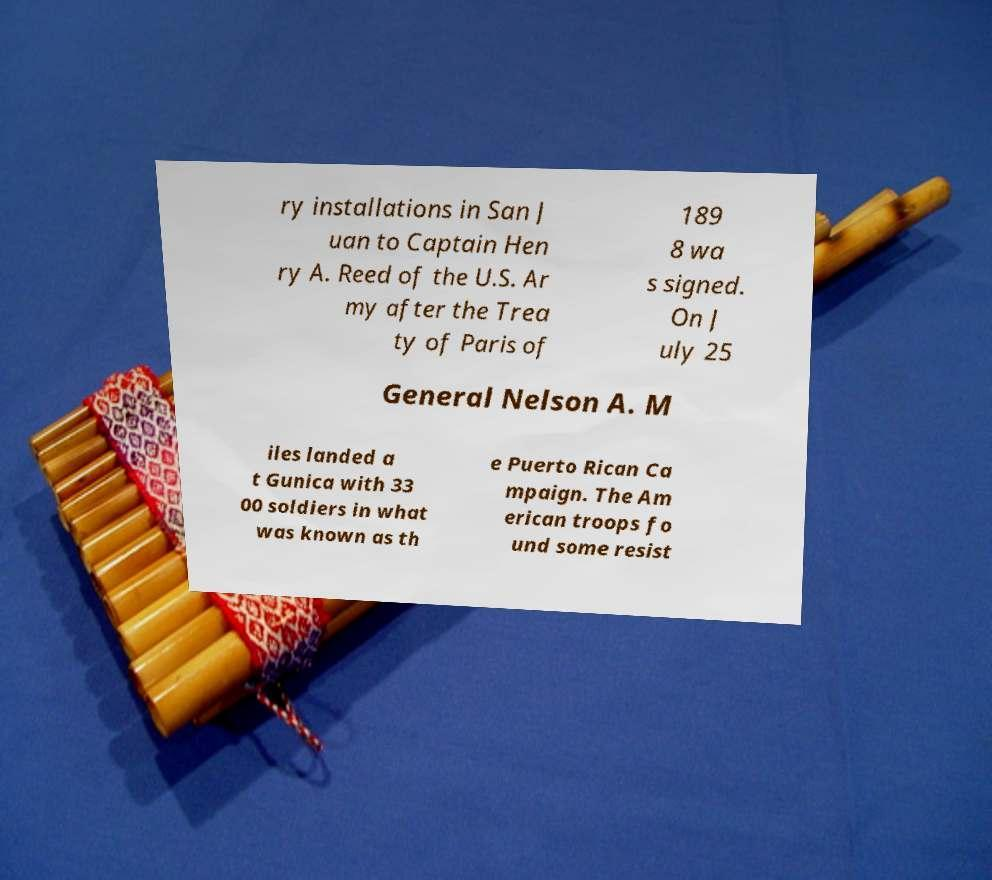For documentation purposes, I need the text within this image transcribed. Could you provide that? ry installations in San J uan to Captain Hen ry A. Reed of the U.S. Ar my after the Trea ty of Paris of 189 8 wa s signed. On J uly 25 General Nelson A. M iles landed a t Gunica with 33 00 soldiers in what was known as th e Puerto Rican Ca mpaign. The Am erican troops fo und some resist 